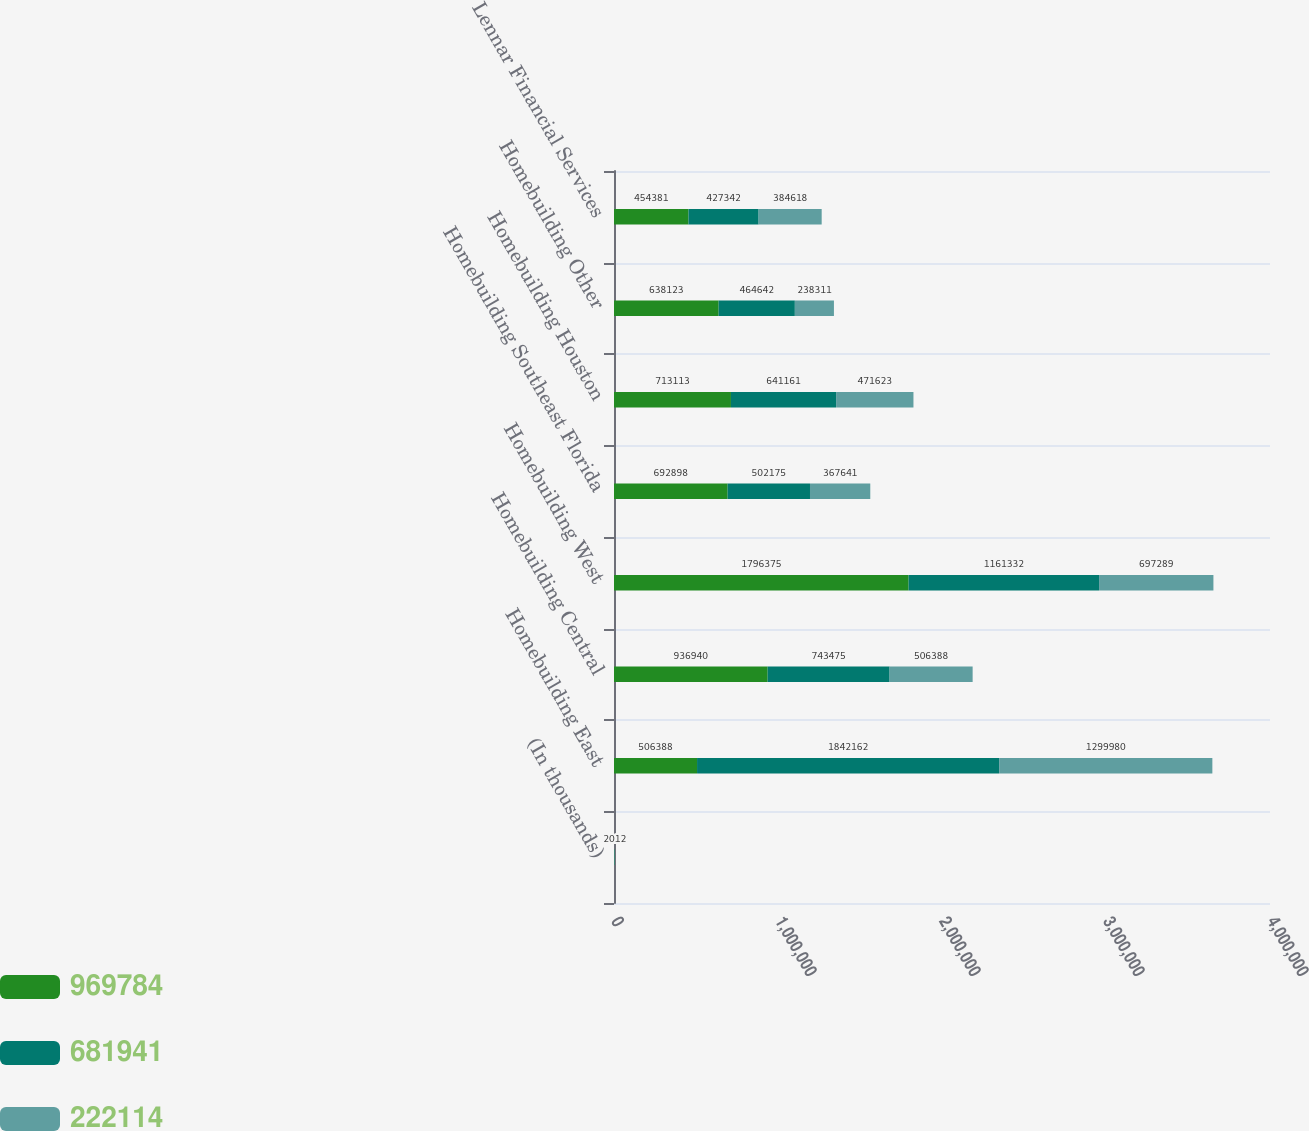Convert chart. <chart><loc_0><loc_0><loc_500><loc_500><stacked_bar_chart><ecel><fcel>(In thousands)<fcel>Homebuilding East<fcel>Homebuilding Central<fcel>Homebuilding West<fcel>Homebuilding Southeast Florida<fcel>Homebuilding Houston<fcel>Homebuilding Other<fcel>Lennar Financial Services<nl><fcel>969784<fcel>2014<fcel>506388<fcel>936940<fcel>1.79638e+06<fcel>692898<fcel>713113<fcel>638123<fcel>454381<nl><fcel>681941<fcel>2013<fcel>1.84216e+06<fcel>743475<fcel>1.16133e+06<fcel>502175<fcel>641161<fcel>464642<fcel>427342<nl><fcel>222114<fcel>2012<fcel>1.29998e+06<fcel>506388<fcel>697289<fcel>367641<fcel>471623<fcel>238311<fcel>384618<nl></chart> 